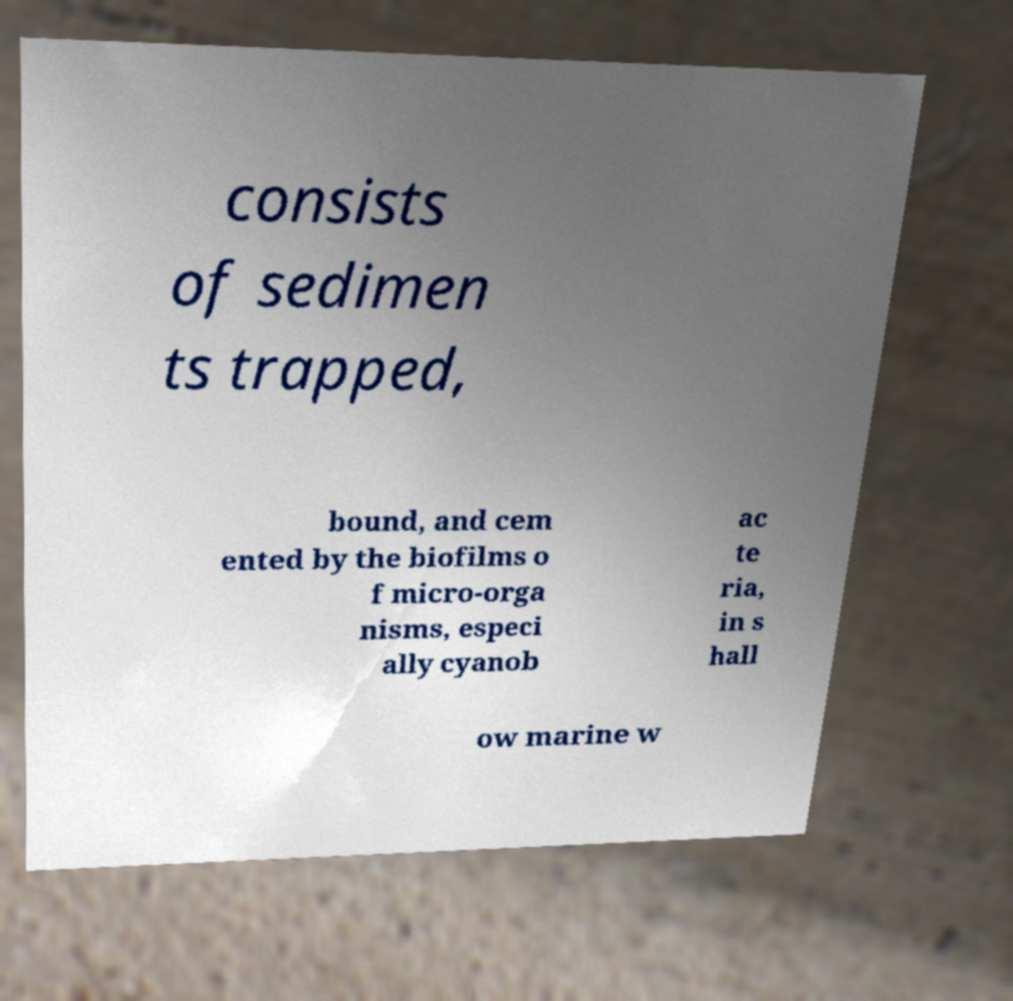Can you read and provide the text displayed in the image?This photo seems to have some interesting text. Can you extract and type it out for me? consists of sedimen ts trapped, bound, and cem ented by the biofilms o f micro-orga nisms, especi ally cyanob ac te ria, in s hall ow marine w 